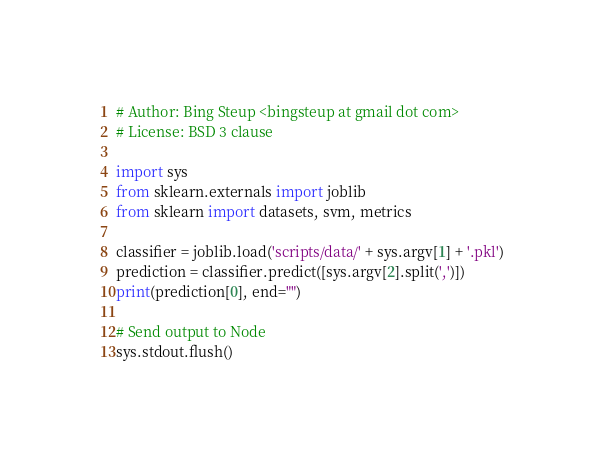Convert code to text. <code><loc_0><loc_0><loc_500><loc_500><_Python_># Author: Bing Steup <bingsteup at gmail dot com>
# License: BSD 3 clause

import sys
from sklearn.externals import joblib
from sklearn import datasets, svm, metrics

classifier = joblib.load('scripts/data/' + sys.argv[1] + '.pkl')
prediction = classifier.predict([sys.argv[2].split(',')])
print(prediction[0], end="")

# Send output to Node
sys.stdout.flush()
</code> 